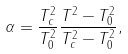<formula> <loc_0><loc_0><loc_500><loc_500>\alpha = \frac { T _ { c } ^ { 2 } } { T _ { 0 } ^ { 2 } } \frac { T ^ { 2 } - T _ { 0 } ^ { 2 } } { T _ { c } ^ { 2 } - T _ { 0 } ^ { 2 } } ,</formula> 